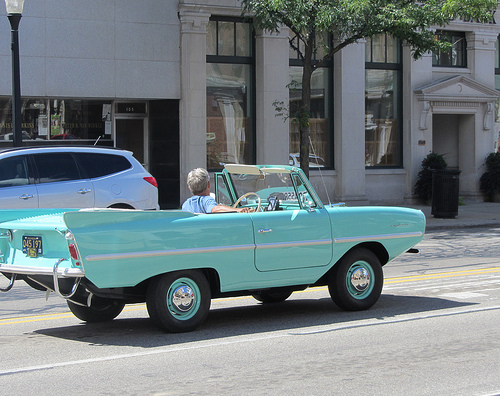<image>
Is there a car to the left of the car? Yes. From this viewpoint, the car is positioned to the left side relative to the car. 